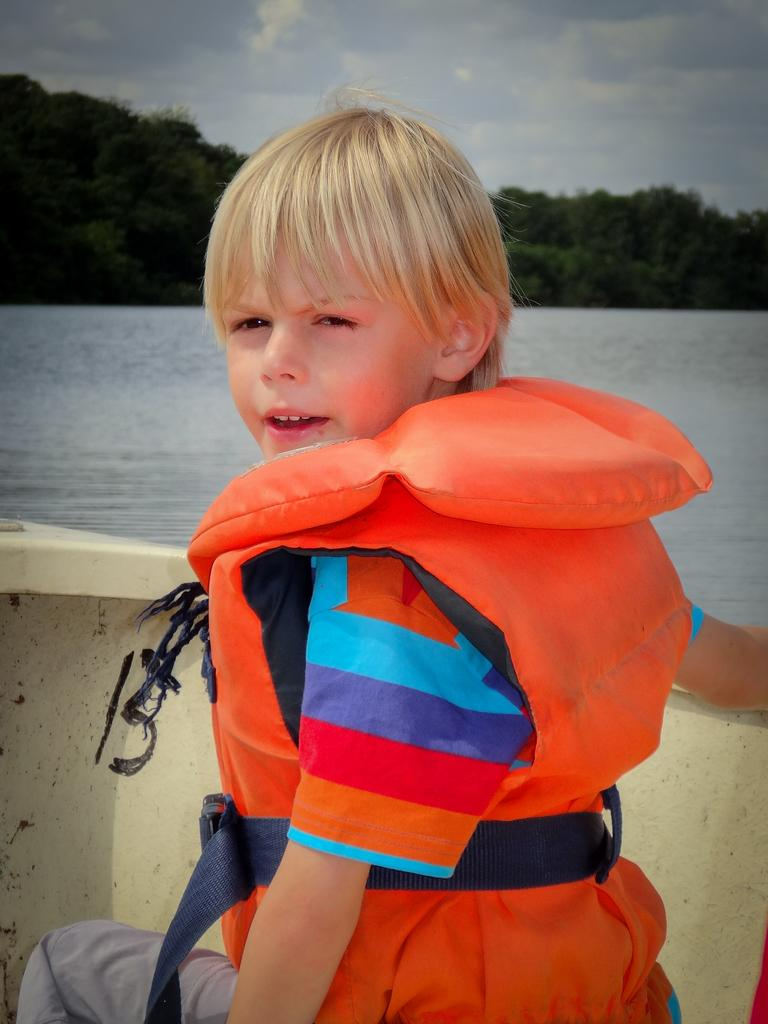Who is in the image? There is a boy in the image. What is the boy wearing? The boy is wearing a life jacket. Where is the boy sitting? The boy is sitting in a boat. What can be seen in the background of the image? There are trees and water visible in the image. How would you describe the weather in the image? The sky is cloudy in the image. What type of pipe is visible in the image? There is no pipe present in the image. What sign can be seen near the trees in the image? There is no sign visible in the image. 